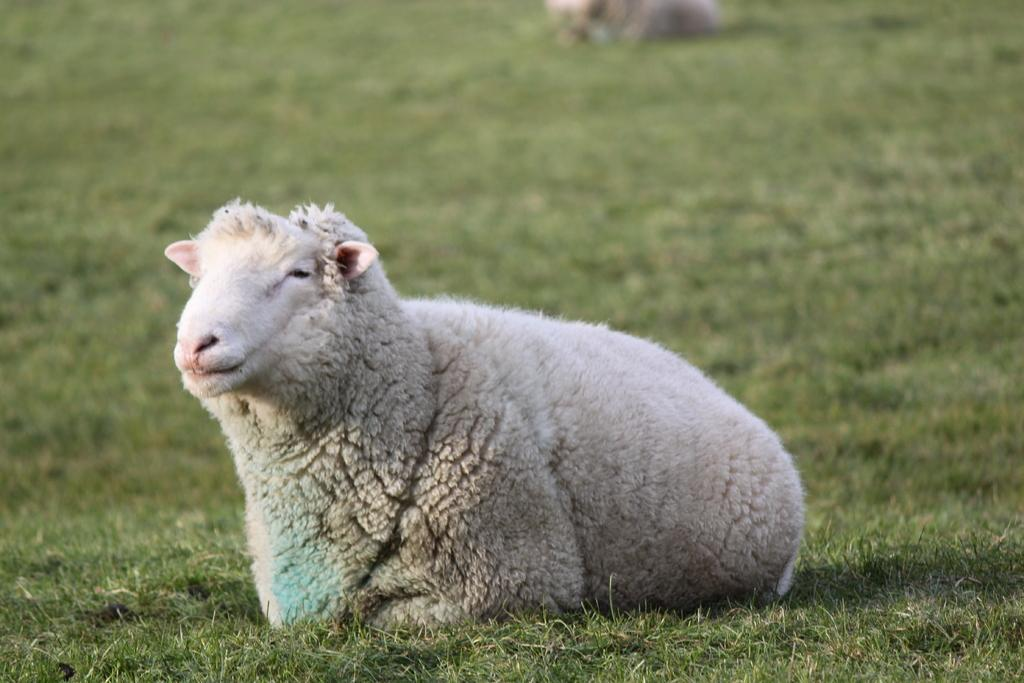What type of animals are present in the image? There are sheep in the image. What is the ground covered with in the image? There is grass on the ground in the image. How many shelves can be seen in the image? There are no shelves present in the image. What is the chance of winning a prize in the image? There is no indication of a prize or any game in the image, so it's not possible to determine the chance of winning. 